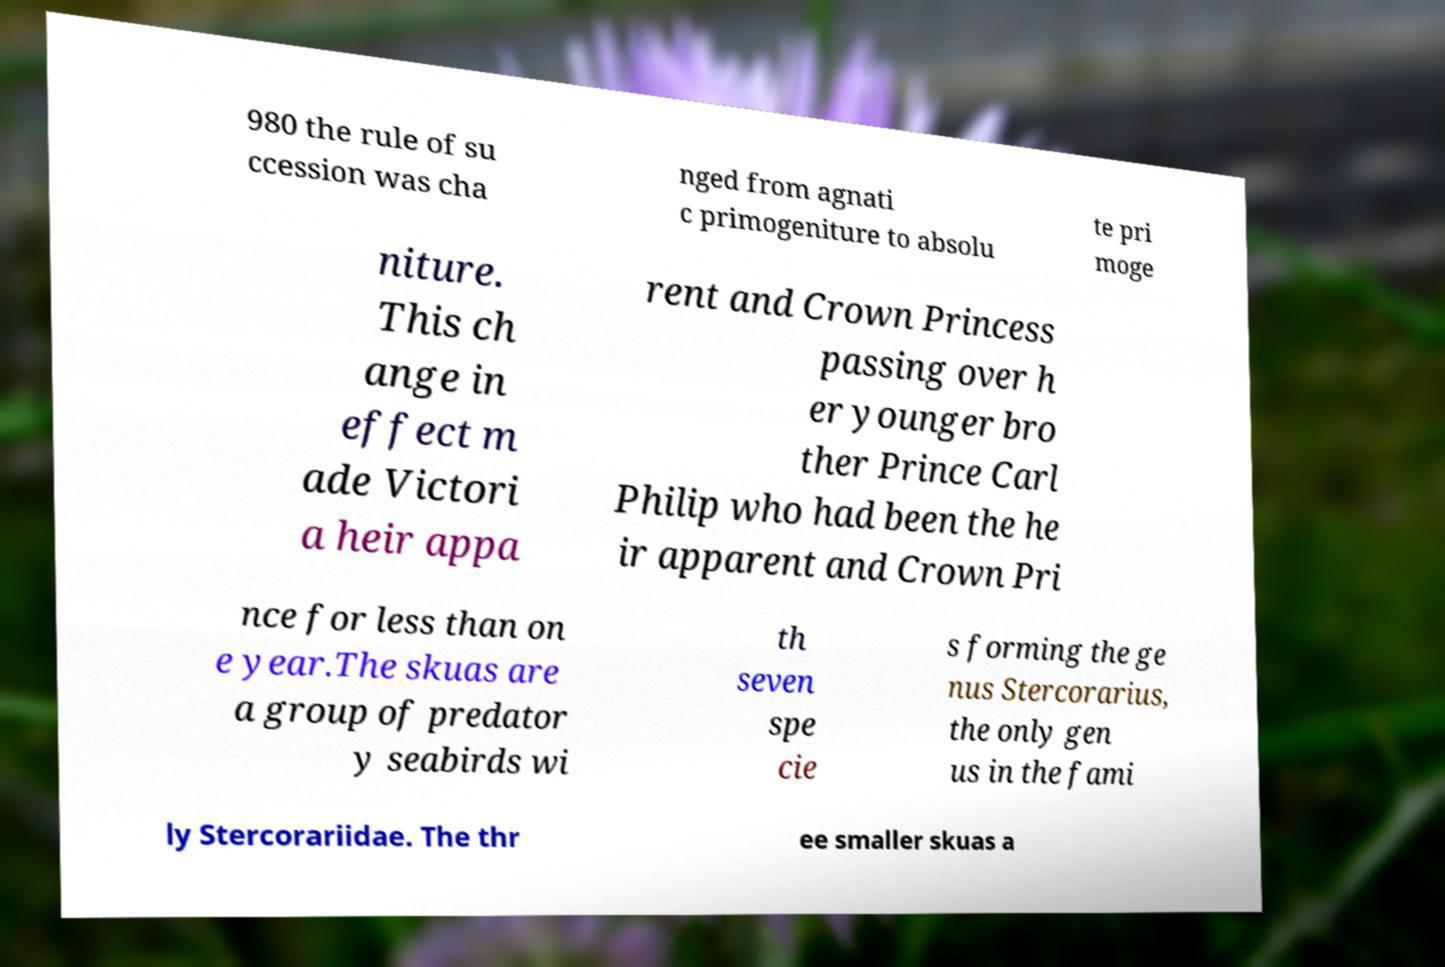What messages or text are displayed in this image? I need them in a readable, typed format. 980 the rule of su ccession was cha nged from agnati c primogeniture to absolu te pri moge niture. This ch ange in effect m ade Victori a heir appa rent and Crown Princess passing over h er younger bro ther Prince Carl Philip who had been the he ir apparent and Crown Pri nce for less than on e year.The skuas are a group of predator y seabirds wi th seven spe cie s forming the ge nus Stercorarius, the only gen us in the fami ly Stercorariidae. The thr ee smaller skuas a 